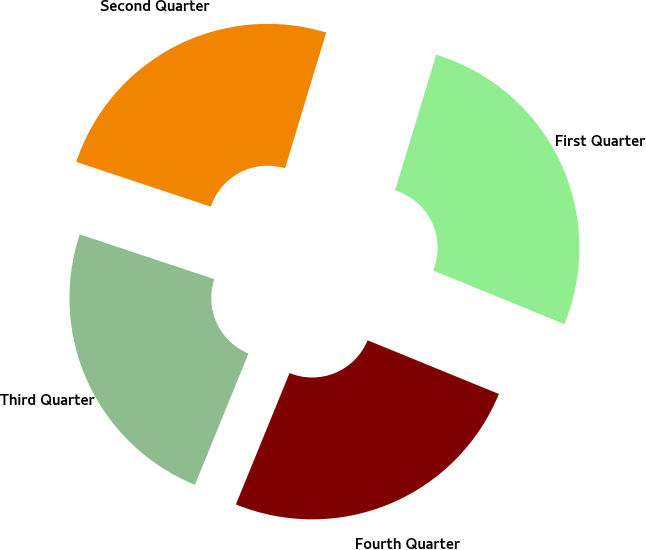Convert chart to OTSL. <chart><loc_0><loc_0><loc_500><loc_500><pie_chart><fcel>First Quarter<fcel>Second Quarter<fcel>Third Quarter<fcel>Fourth Quarter<nl><fcel>26.49%<fcel>24.57%<fcel>23.94%<fcel>24.99%<nl></chart> 